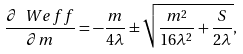<formula> <loc_0><loc_0><loc_500><loc_500>\frac { \partial \ W e f f } { \partial m } = - \frac { m } { 4 \lambda } \pm \sqrt { \frac { m ^ { 2 } } { 1 6 \lambda ^ { 2 } } + \frac { S } { 2 \lambda } } ,</formula> 